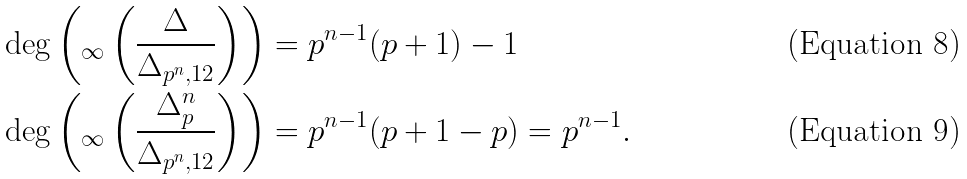<formula> <loc_0><loc_0><loc_500><loc_500>& \deg \left ( _ { \infty } \left ( \frac { \Delta } { \Delta _ { p ^ { n } , 1 2 } } \right ) \right ) = p ^ { n - 1 } ( p + 1 ) - 1 \\ & \deg \left ( _ { \infty } \left ( \frac { \Delta _ { p } ^ { n } } { \Delta _ { p ^ { n } , 1 2 } } \right ) \right ) = p ^ { n - 1 } ( p + 1 - p ) = p ^ { n - 1 } .</formula> 